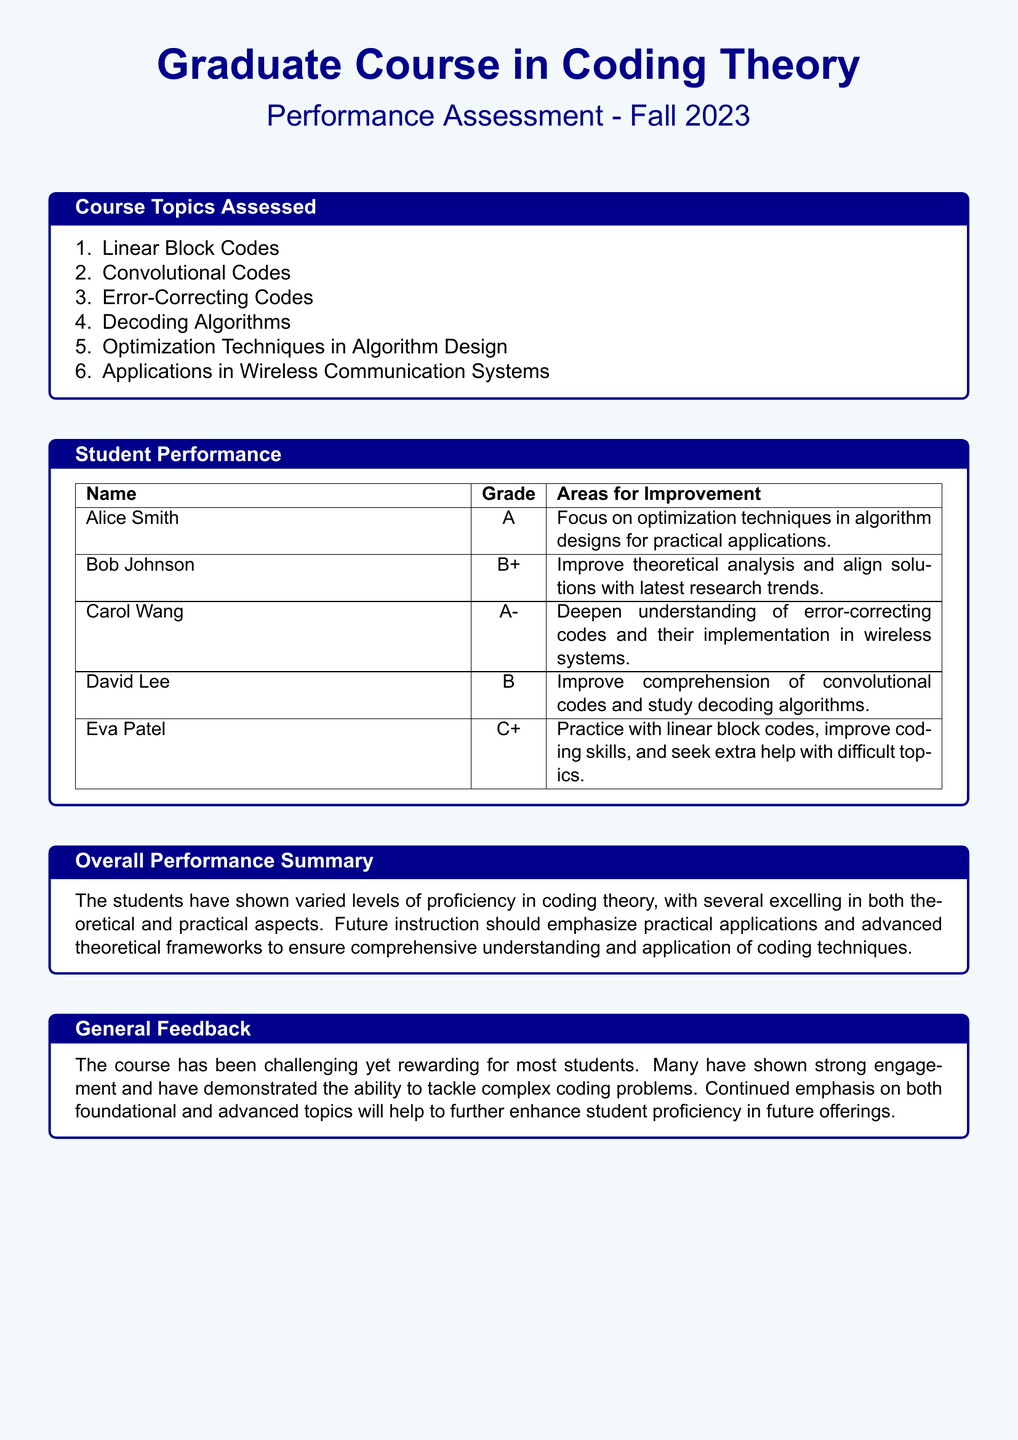What are the names of the students assessed? The document lists the names of students in the performance assessment section.
Answer: Alice Smith, Bob Johnson, Carol Wang, David Lee, Eva Patel What grade did Carol Wang receive? The grade given to Carol Wang is specified in the Student Performance section.
Answer: A- What is the area for improvement for David Lee? The document outlines specific areas for improvement for each student.
Answer: Improve comprehension of convolutional codes and study decoding algorithms How many course topics were assessed? The number of topics is listed in the Course Topics Assessed section.
Answer: Six What characterizes the overall performance summary? The overall performance summary reflects on the students' proficiency levels in coding theory.
Answer: Varied levels of proficiency What feedback was given about the course? The general feedback provides insights into the overall effectiveness of the course.
Answer: Challenging yet rewarding Which student received the lowest grade? The document indicates the grades assigned to each student.
Answer: Eva Patel What major coding topic should Eva Patel focus on? The document specifies areas for improvement for each student, including Eva Patel.
Answer: Linear block codes What does the course focus on according to the assessed topics? The course topics detail areas studied during the course.
Answer: Applications in Wireless Communication Systems 